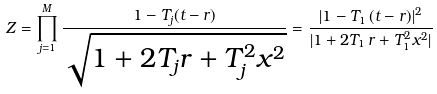Convert formula to latex. <formula><loc_0><loc_0><loc_500><loc_500>Z = \prod _ { j = 1 } ^ { M } \frac { 1 - T _ { j } ( t - r ) } { \sqrt { 1 + 2 T _ { j } r + T _ { j } ^ { 2 } x ^ { 2 } } } = \frac { | 1 - T _ { 1 } \, ( t - r ) | ^ { 2 } } { | 1 + 2 T _ { 1 } \, r + T _ { 1 } ^ { 2 } x ^ { 2 } | }</formula> 